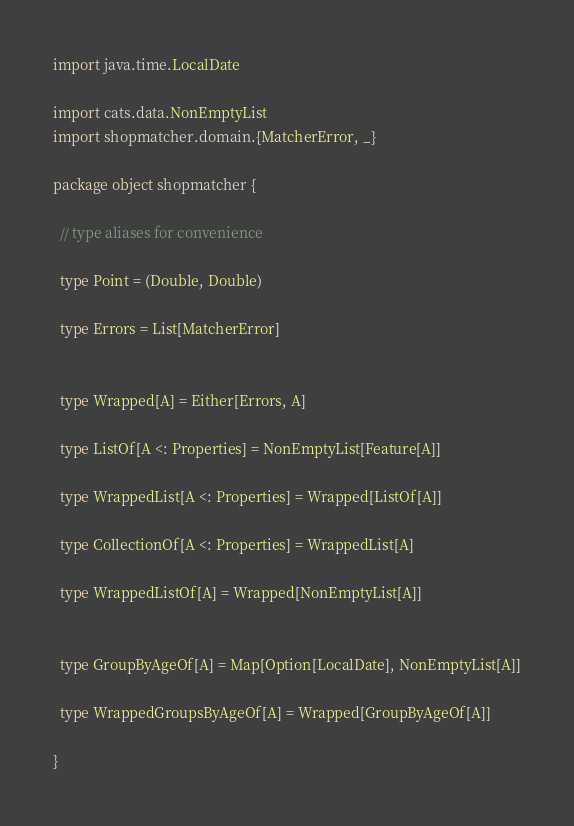Convert code to text. <code><loc_0><loc_0><loc_500><loc_500><_Scala_>import java.time.LocalDate

import cats.data.NonEmptyList
import shopmatcher.domain.{MatcherError, _}

package object shopmatcher {

  // type aliases for convenience

  type Point = (Double, Double)

  type Errors = List[MatcherError]


  type Wrapped[A] = Either[Errors, A]

  type ListOf[A <: Properties] = NonEmptyList[Feature[A]]

  type WrappedList[A <: Properties] = Wrapped[ListOf[A]]

  type CollectionOf[A <: Properties] = WrappedList[A]

  type WrappedListOf[A] = Wrapped[NonEmptyList[A]]


  type GroupByAgeOf[A] = Map[Option[LocalDate], NonEmptyList[A]]

  type WrappedGroupsByAgeOf[A] = Wrapped[GroupByAgeOf[A]]

}</code> 